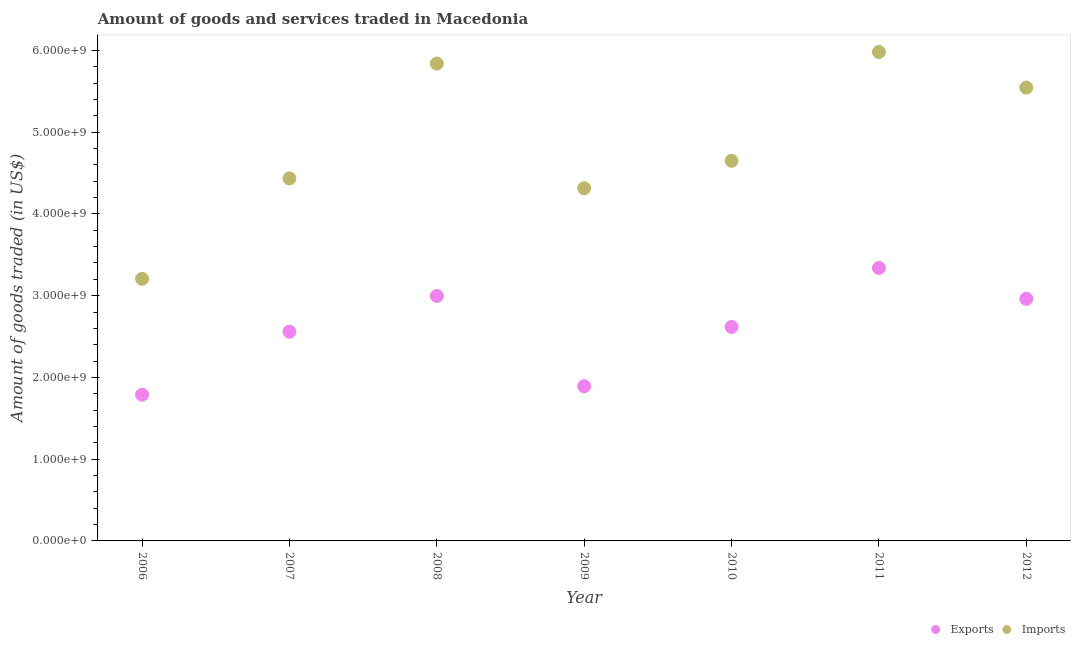How many different coloured dotlines are there?
Give a very brief answer. 2. What is the amount of goods imported in 2007?
Offer a terse response. 4.43e+09. Across all years, what is the maximum amount of goods imported?
Make the answer very short. 5.98e+09. Across all years, what is the minimum amount of goods imported?
Give a very brief answer. 3.21e+09. In which year was the amount of goods exported maximum?
Give a very brief answer. 2011. What is the total amount of goods imported in the graph?
Make the answer very short. 3.40e+1. What is the difference between the amount of goods imported in 2008 and that in 2010?
Offer a terse response. 1.19e+09. What is the difference between the amount of goods exported in 2012 and the amount of goods imported in 2008?
Keep it short and to the point. -2.88e+09. What is the average amount of goods exported per year?
Offer a very short reply. 2.59e+09. In the year 2012, what is the difference between the amount of goods exported and amount of goods imported?
Provide a succinct answer. -2.58e+09. What is the ratio of the amount of goods imported in 2006 to that in 2007?
Your answer should be compact. 0.72. What is the difference between the highest and the second highest amount of goods imported?
Your answer should be very brief. 1.41e+08. What is the difference between the highest and the lowest amount of goods exported?
Make the answer very short. 1.55e+09. In how many years, is the amount of goods imported greater than the average amount of goods imported taken over all years?
Offer a terse response. 3. Is the sum of the amount of goods exported in 2010 and 2011 greater than the maximum amount of goods imported across all years?
Make the answer very short. No. Does the amount of goods imported monotonically increase over the years?
Offer a very short reply. No. Is the amount of goods exported strictly greater than the amount of goods imported over the years?
Your answer should be very brief. No. Is the amount of goods exported strictly less than the amount of goods imported over the years?
Your answer should be compact. Yes. How many dotlines are there?
Provide a succinct answer. 2. What is the difference between two consecutive major ticks on the Y-axis?
Offer a terse response. 1.00e+09. Are the values on the major ticks of Y-axis written in scientific E-notation?
Provide a succinct answer. Yes. Does the graph contain any zero values?
Provide a succinct answer. No. Does the graph contain grids?
Keep it short and to the point. No. Where does the legend appear in the graph?
Provide a succinct answer. Bottom right. What is the title of the graph?
Offer a very short reply. Amount of goods and services traded in Macedonia. What is the label or title of the Y-axis?
Provide a short and direct response. Amount of goods traded (in US$). What is the Amount of goods traded (in US$) in Exports in 2006?
Ensure brevity in your answer.  1.79e+09. What is the Amount of goods traded (in US$) in Imports in 2006?
Keep it short and to the point. 3.21e+09. What is the Amount of goods traded (in US$) of Exports in 2007?
Your answer should be compact. 2.56e+09. What is the Amount of goods traded (in US$) of Imports in 2007?
Offer a very short reply. 4.43e+09. What is the Amount of goods traded (in US$) in Exports in 2008?
Offer a terse response. 3.00e+09. What is the Amount of goods traded (in US$) of Imports in 2008?
Offer a terse response. 5.84e+09. What is the Amount of goods traded (in US$) of Exports in 2009?
Ensure brevity in your answer.  1.89e+09. What is the Amount of goods traded (in US$) of Imports in 2009?
Provide a short and direct response. 4.31e+09. What is the Amount of goods traded (in US$) in Exports in 2010?
Your answer should be very brief. 2.62e+09. What is the Amount of goods traded (in US$) of Imports in 2010?
Your answer should be very brief. 4.65e+09. What is the Amount of goods traded (in US$) of Exports in 2011?
Keep it short and to the point. 3.34e+09. What is the Amount of goods traded (in US$) in Imports in 2011?
Offer a very short reply. 5.98e+09. What is the Amount of goods traded (in US$) in Exports in 2012?
Ensure brevity in your answer.  2.96e+09. What is the Amount of goods traded (in US$) in Imports in 2012?
Make the answer very short. 5.54e+09. Across all years, what is the maximum Amount of goods traded (in US$) of Exports?
Offer a very short reply. 3.34e+09. Across all years, what is the maximum Amount of goods traded (in US$) in Imports?
Keep it short and to the point. 5.98e+09. Across all years, what is the minimum Amount of goods traded (in US$) in Exports?
Make the answer very short. 1.79e+09. Across all years, what is the minimum Amount of goods traded (in US$) in Imports?
Ensure brevity in your answer.  3.21e+09. What is the total Amount of goods traded (in US$) of Exports in the graph?
Keep it short and to the point. 1.82e+1. What is the total Amount of goods traded (in US$) of Imports in the graph?
Offer a very short reply. 3.40e+1. What is the difference between the Amount of goods traded (in US$) of Exports in 2006 and that in 2007?
Offer a very short reply. -7.71e+08. What is the difference between the Amount of goods traded (in US$) in Imports in 2006 and that in 2007?
Your answer should be compact. -1.23e+09. What is the difference between the Amount of goods traded (in US$) of Exports in 2006 and that in 2008?
Offer a very short reply. -1.21e+09. What is the difference between the Amount of goods traded (in US$) in Imports in 2006 and that in 2008?
Give a very brief answer. -2.63e+09. What is the difference between the Amount of goods traded (in US$) of Exports in 2006 and that in 2009?
Your response must be concise. -1.04e+08. What is the difference between the Amount of goods traded (in US$) in Imports in 2006 and that in 2009?
Provide a short and direct response. -1.11e+09. What is the difference between the Amount of goods traded (in US$) in Exports in 2006 and that in 2010?
Your answer should be compact. -8.29e+08. What is the difference between the Amount of goods traded (in US$) in Imports in 2006 and that in 2010?
Make the answer very short. -1.44e+09. What is the difference between the Amount of goods traded (in US$) of Exports in 2006 and that in 2011?
Offer a very short reply. -1.55e+09. What is the difference between the Amount of goods traded (in US$) in Imports in 2006 and that in 2011?
Keep it short and to the point. -2.77e+09. What is the difference between the Amount of goods traded (in US$) in Exports in 2006 and that in 2012?
Ensure brevity in your answer.  -1.17e+09. What is the difference between the Amount of goods traded (in US$) in Imports in 2006 and that in 2012?
Ensure brevity in your answer.  -2.34e+09. What is the difference between the Amount of goods traded (in US$) in Exports in 2007 and that in 2008?
Your answer should be very brief. -4.38e+08. What is the difference between the Amount of goods traded (in US$) of Imports in 2007 and that in 2008?
Give a very brief answer. -1.40e+09. What is the difference between the Amount of goods traded (in US$) of Exports in 2007 and that in 2009?
Provide a succinct answer. 6.67e+08. What is the difference between the Amount of goods traded (in US$) of Imports in 2007 and that in 2009?
Offer a terse response. 1.21e+08. What is the difference between the Amount of goods traded (in US$) of Exports in 2007 and that in 2010?
Make the answer very short. -5.85e+07. What is the difference between the Amount of goods traded (in US$) of Imports in 2007 and that in 2010?
Offer a terse response. -2.15e+08. What is the difference between the Amount of goods traded (in US$) of Exports in 2007 and that in 2011?
Offer a very short reply. -7.80e+08. What is the difference between the Amount of goods traded (in US$) of Imports in 2007 and that in 2011?
Offer a terse response. -1.55e+09. What is the difference between the Amount of goods traded (in US$) in Exports in 2007 and that in 2012?
Make the answer very short. -4.02e+08. What is the difference between the Amount of goods traded (in US$) of Imports in 2007 and that in 2012?
Provide a short and direct response. -1.11e+09. What is the difference between the Amount of goods traded (in US$) in Exports in 2008 and that in 2009?
Give a very brief answer. 1.10e+09. What is the difference between the Amount of goods traded (in US$) of Imports in 2008 and that in 2009?
Give a very brief answer. 1.53e+09. What is the difference between the Amount of goods traded (in US$) in Exports in 2008 and that in 2010?
Your response must be concise. 3.79e+08. What is the difference between the Amount of goods traded (in US$) in Imports in 2008 and that in 2010?
Give a very brief answer. 1.19e+09. What is the difference between the Amount of goods traded (in US$) of Exports in 2008 and that in 2011?
Keep it short and to the point. -3.42e+08. What is the difference between the Amount of goods traded (in US$) in Imports in 2008 and that in 2011?
Ensure brevity in your answer.  -1.41e+08. What is the difference between the Amount of goods traded (in US$) in Exports in 2008 and that in 2012?
Offer a terse response. 3.56e+07. What is the difference between the Amount of goods traded (in US$) of Imports in 2008 and that in 2012?
Your answer should be compact. 2.94e+08. What is the difference between the Amount of goods traded (in US$) in Exports in 2009 and that in 2010?
Make the answer very short. -7.25e+08. What is the difference between the Amount of goods traded (in US$) in Imports in 2009 and that in 2010?
Give a very brief answer. -3.35e+08. What is the difference between the Amount of goods traded (in US$) of Exports in 2009 and that in 2011?
Offer a very short reply. -1.45e+09. What is the difference between the Amount of goods traded (in US$) of Imports in 2009 and that in 2011?
Provide a short and direct response. -1.67e+09. What is the difference between the Amount of goods traded (in US$) in Exports in 2009 and that in 2012?
Your response must be concise. -1.07e+09. What is the difference between the Amount of goods traded (in US$) of Imports in 2009 and that in 2012?
Provide a short and direct response. -1.23e+09. What is the difference between the Amount of goods traded (in US$) in Exports in 2010 and that in 2011?
Offer a terse response. -7.21e+08. What is the difference between the Amount of goods traded (in US$) of Imports in 2010 and that in 2011?
Make the answer very short. -1.33e+09. What is the difference between the Amount of goods traded (in US$) of Exports in 2010 and that in 2012?
Keep it short and to the point. -3.44e+08. What is the difference between the Amount of goods traded (in US$) of Imports in 2010 and that in 2012?
Ensure brevity in your answer.  -8.96e+08. What is the difference between the Amount of goods traded (in US$) in Exports in 2011 and that in 2012?
Offer a very short reply. 3.78e+08. What is the difference between the Amount of goods traded (in US$) in Imports in 2011 and that in 2012?
Give a very brief answer. 4.35e+08. What is the difference between the Amount of goods traded (in US$) in Exports in 2006 and the Amount of goods traded (in US$) in Imports in 2007?
Ensure brevity in your answer.  -2.65e+09. What is the difference between the Amount of goods traded (in US$) of Exports in 2006 and the Amount of goods traded (in US$) of Imports in 2008?
Make the answer very short. -4.05e+09. What is the difference between the Amount of goods traded (in US$) of Exports in 2006 and the Amount of goods traded (in US$) of Imports in 2009?
Provide a short and direct response. -2.53e+09. What is the difference between the Amount of goods traded (in US$) of Exports in 2006 and the Amount of goods traded (in US$) of Imports in 2010?
Your answer should be very brief. -2.86e+09. What is the difference between the Amount of goods traded (in US$) of Exports in 2006 and the Amount of goods traded (in US$) of Imports in 2011?
Give a very brief answer. -4.19e+09. What is the difference between the Amount of goods traded (in US$) of Exports in 2006 and the Amount of goods traded (in US$) of Imports in 2012?
Provide a succinct answer. -3.76e+09. What is the difference between the Amount of goods traded (in US$) of Exports in 2007 and the Amount of goods traded (in US$) of Imports in 2008?
Provide a short and direct response. -3.28e+09. What is the difference between the Amount of goods traded (in US$) in Exports in 2007 and the Amount of goods traded (in US$) in Imports in 2009?
Offer a terse response. -1.76e+09. What is the difference between the Amount of goods traded (in US$) of Exports in 2007 and the Amount of goods traded (in US$) of Imports in 2010?
Offer a terse response. -2.09e+09. What is the difference between the Amount of goods traded (in US$) of Exports in 2007 and the Amount of goods traded (in US$) of Imports in 2011?
Ensure brevity in your answer.  -3.42e+09. What is the difference between the Amount of goods traded (in US$) in Exports in 2007 and the Amount of goods traded (in US$) in Imports in 2012?
Your answer should be very brief. -2.99e+09. What is the difference between the Amount of goods traded (in US$) in Exports in 2008 and the Amount of goods traded (in US$) in Imports in 2009?
Give a very brief answer. -1.32e+09. What is the difference between the Amount of goods traded (in US$) of Exports in 2008 and the Amount of goods traded (in US$) of Imports in 2010?
Your answer should be compact. -1.65e+09. What is the difference between the Amount of goods traded (in US$) in Exports in 2008 and the Amount of goods traded (in US$) in Imports in 2011?
Offer a very short reply. -2.98e+09. What is the difference between the Amount of goods traded (in US$) in Exports in 2008 and the Amount of goods traded (in US$) in Imports in 2012?
Offer a very short reply. -2.55e+09. What is the difference between the Amount of goods traded (in US$) in Exports in 2009 and the Amount of goods traded (in US$) in Imports in 2010?
Offer a terse response. -2.76e+09. What is the difference between the Amount of goods traded (in US$) in Exports in 2009 and the Amount of goods traded (in US$) in Imports in 2011?
Provide a short and direct response. -4.09e+09. What is the difference between the Amount of goods traded (in US$) of Exports in 2009 and the Amount of goods traded (in US$) of Imports in 2012?
Your response must be concise. -3.65e+09. What is the difference between the Amount of goods traded (in US$) in Exports in 2010 and the Amount of goods traded (in US$) in Imports in 2011?
Provide a short and direct response. -3.36e+09. What is the difference between the Amount of goods traded (in US$) of Exports in 2010 and the Amount of goods traded (in US$) of Imports in 2012?
Your response must be concise. -2.93e+09. What is the difference between the Amount of goods traded (in US$) of Exports in 2011 and the Amount of goods traded (in US$) of Imports in 2012?
Ensure brevity in your answer.  -2.21e+09. What is the average Amount of goods traded (in US$) in Exports per year?
Ensure brevity in your answer.  2.59e+09. What is the average Amount of goods traded (in US$) in Imports per year?
Offer a terse response. 4.85e+09. In the year 2006, what is the difference between the Amount of goods traded (in US$) of Exports and Amount of goods traded (in US$) of Imports?
Your response must be concise. -1.42e+09. In the year 2007, what is the difference between the Amount of goods traded (in US$) in Exports and Amount of goods traded (in US$) in Imports?
Your answer should be compact. -1.88e+09. In the year 2008, what is the difference between the Amount of goods traded (in US$) in Exports and Amount of goods traded (in US$) in Imports?
Provide a short and direct response. -2.84e+09. In the year 2009, what is the difference between the Amount of goods traded (in US$) in Exports and Amount of goods traded (in US$) in Imports?
Offer a terse response. -2.42e+09. In the year 2010, what is the difference between the Amount of goods traded (in US$) of Exports and Amount of goods traded (in US$) of Imports?
Your answer should be compact. -2.03e+09. In the year 2011, what is the difference between the Amount of goods traded (in US$) of Exports and Amount of goods traded (in US$) of Imports?
Your response must be concise. -2.64e+09. In the year 2012, what is the difference between the Amount of goods traded (in US$) in Exports and Amount of goods traded (in US$) in Imports?
Keep it short and to the point. -2.58e+09. What is the ratio of the Amount of goods traded (in US$) in Exports in 2006 to that in 2007?
Offer a terse response. 0.7. What is the ratio of the Amount of goods traded (in US$) of Imports in 2006 to that in 2007?
Your response must be concise. 0.72. What is the ratio of the Amount of goods traded (in US$) in Exports in 2006 to that in 2008?
Make the answer very short. 0.6. What is the ratio of the Amount of goods traded (in US$) in Imports in 2006 to that in 2008?
Offer a very short reply. 0.55. What is the ratio of the Amount of goods traded (in US$) of Exports in 2006 to that in 2009?
Ensure brevity in your answer.  0.95. What is the ratio of the Amount of goods traded (in US$) of Imports in 2006 to that in 2009?
Offer a terse response. 0.74. What is the ratio of the Amount of goods traded (in US$) in Exports in 2006 to that in 2010?
Offer a terse response. 0.68. What is the ratio of the Amount of goods traded (in US$) in Imports in 2006 to that in 2010?
Give a very brief answer. 0.69. What is the ratio of the Amount of goods traded (in US$) of Exports in 2006 to that in 2011?
Give a very brief answer. 0.54. What is the ratio of the Amount of goods traded (in US$) in Imports in 2006 to that in 2011?
Make the answer very short. 0.54. What is the ratio of the Amount of goods traded (in US$) of Exports in 2006 to that in 2012?
Your answer should be compact. 0.6. What is the ratio of the Amount of goods traded (in US$) of Imports in 2006 to that in 2012?
Provide a succinct answer. 0.58. What is the ratio of the Amount of goods traded (in US$) of Exports in 2007 to that in 2008?
Give a very brief answer. 0.85. What is the ratio of the Amount of goods traded (in US$) in Imports in 2007 to that in 2008?
Make the answer very short. 0.76. What is the ratio of the Amount of goods traded (in US$) in Exports in 2007 to that in 2009?
Give a very brief answer. 1.35. What is the ratio of the Amount of goods traded (in US$) in Imports in 2007 to that in 2009?
Offer a terse response. 1.03. What is the ratio of the Amount of goods traded (in US$) in Exports in 2007 to that in 2010?
Keep it short and to the point. 0.98. What is the ratio of the Amount of goods traded (in US$) in Imports in 2007 to that in 2010?
Offer a terse response. 0.95. What is the ratio of the Amount of goods traded (in US$) in Exports in 2007 to that in 2011?
Offer a terse response. 0.77. What is the ratio of the Amount of goods traded (in US$) in Imports in 2007 to that in 2011?
Your answer should be very brief. 0.74. What is the ratio of the Amount of goods traded (in US$) in Exports in 2007 to that in 2012?
Provide a short and direct response. 0.86. What is the ratio of the Amount of goods traded (in US$) of Imports in 2007 to that in 2012?
Ensure brevity in your answer.  0.8. What is the ratio of the Amount of goods traded (in US$) in Exports in 2008 to that in 2009?
Provide a succinct answer. 1.58. What is the ratio of the Amount of goods traded (in US$) in Imports in 2008 to that in 2009?
Provide a succinct answer. 1.35. What is the ratio of the Amount of goods traded (in US$) in Exports in 2008 to that in 2010?
Keep it short and to the point. 1.14. What is the ratio of the Amount of goods traded (in US$) of Imports in 2008 to that in 2010?
Your response must be concise. 1.26. What is the ratio of the Amount of goods traded (in US$) in Exports in 2008 to that in 2011?
Provide a succinct answer. 0.9. What is the ratio of the Amount of goods traded (in US$) of Imports in 2008 to that in 2011?
Provide a short and direct response. 0.98. What is the ratio of the Amount of goods traded (in US$) in Imports in 2008 to that in 2012?
Make the answer very short. 1.05. What is the ratio of the Amount of goods traded (in US$) in Exports in 2009 to that in 2010?
Your response must be concise. 0.72. What is the ratio of the Amount of goods traded (in US$) in Imports in 2009 to that in 2010?
Keep it short and to the point. 0.93. What is the ratio of the Amount of goods traded (in US$) in Exports in 2009 to that in 2011?
Offer a terse response. 0.57. What is the ratio of the Amount of goods traded (in US$) of Imports in 2009 to that in 2011?
Keep it short and to the point. 0.72. What is the ratio of the Amount of goods traded (in US$) of Exports in 2009 to that in 2012?
Provide a succinct answer. 0.64. What is the ratio of the Amount of goods traded (in US$) of Imports in 2009 to that in 2012?
Keep it short and to the point. 0.78. What is the ratio of the Amount of goods traded (in US$) of Exports in 2010 to that in 2011?
Provide a short and direct response. 0.78. What is the ratio of the Amount of goods traded (in US$) in Imports in 2010 to that in 2011?
Provide a short and direct response. 0.78. What is the ratio of the Amount of goods traded (in US$) of Exports in 2010 to that in 2012?
Keep it short and to the point. 0.88. What is the ratio of the Amount of goods traded (in US$) of Imports in 2010 to that in 2012?
Offer a very short reply. 0.84. What is the ratio of the Amount of goods traded (in US$) of Exports in 2011 to that in 2012?
Give a very brief answer. 1.13. What is the ratio of the Amount of goods traded (in US$) of Imports in 2011 to that in 2012?
Keep it short and to the point. 1.08. What is the difference between the highest and the second highest Amount of goods traded (in US$) of Exports?
Offer a terse response. 3.42e+08. What is the difference between the highest and the second highest Amount of goods traded (in US$) of Imports?
Ensure brevity in your answer.  1.41e+08. What is the difference between the highest and the lowest Amount of goods traded (in US$) of Exports?
Provide a succinct answer. 1.55e+09. What is the difference between the highest and the lowest Amount of goods traded (in US$) in Imports?
Your answer should be very brief. 2.77e+09. 